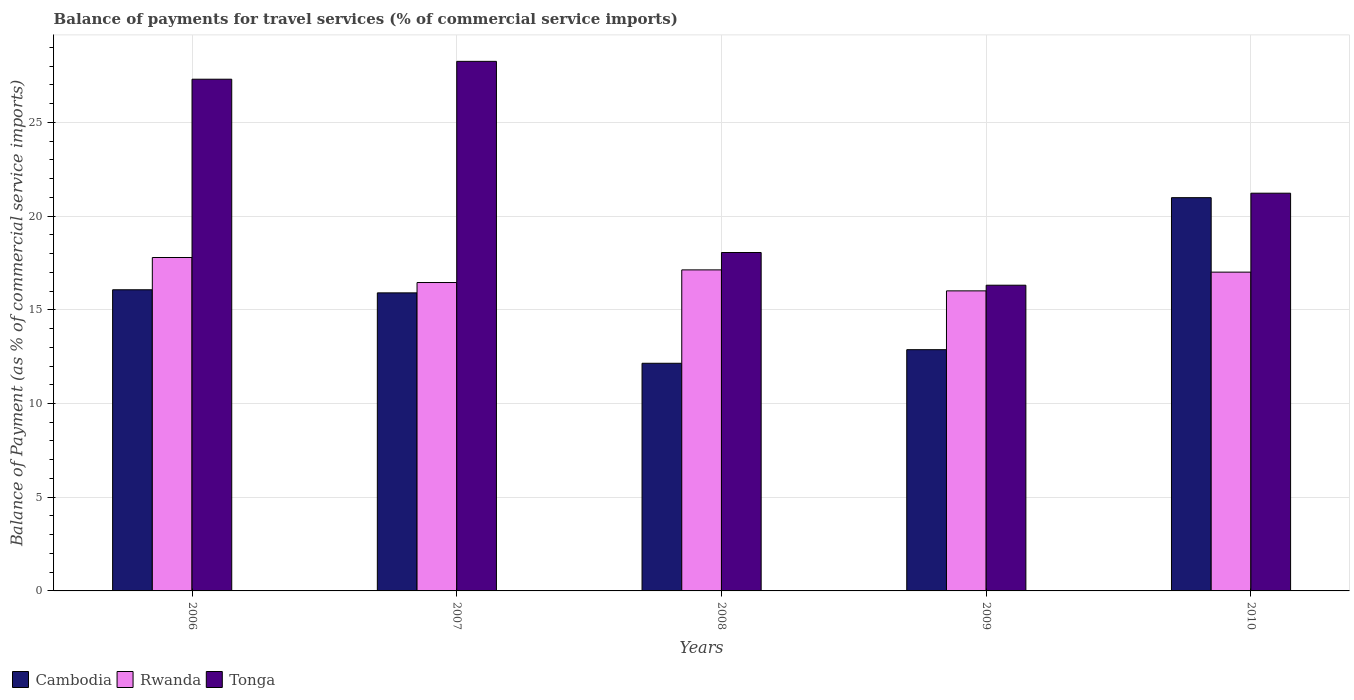How many different coloured bars are there?
Ensure brevity in your answer.  3. How many groups of bars are there?
Ensure brevity in your answer.  5. Are the number of bars per tick equal to the number of legend labels?
Offer a very short reply. Yes. Are the number of bars on each tick of the X-axis equal?
Offer a terse response. Yes. What is the label of the 1st group of bars from the left?
Make the answer very short. 2006. In how many cases, is the number of bars for a given year not equal to the number of legend labels?
Provide a succinct answer. 0. What is the balance of payments for travel services in Cambodia in 2008?
Make the answer very short. 12.15. Across all years, what is the maximum balance of payments for travel services in Rwanda?
Keep it short and to the point. 17.79. Across all years, what is the minimum balance of payments for travel services in Cambodia?
Provide a succinct answer. 12.15. In which year was the balance of payments for travel services in Rwanda minimum?
Provide a short and direct response. 2009. What is the total balance of payments for travel services in Cambodia in the graph?
Give a very brief answer. 77.97. What is the difference between the balance of payments for travel services in Tonga in 2008 and that in 2010?
Provide a succinct answer. -3.16. What is the difference between the balance of payments for travel services in Cambodia in 2008 and the balance of payments for travel services in Tonga in 2006?
Your answer should be very brief. -15.16. What is the average balance of payments for travel services in Cambodia per year?
Provide a succinct answer. 15.59. In the year 2006, what is the difference between the balance of payments for travel services in Cambodia and balance of payments for travel services in Rwanda?
Offer a very short reply. -1.72. What is the ratio of the balance of payments for travel services in Cambodia in 2008 to that in 2010?
Make the answer very short. 0.58. Is the balance of payments for travel services in Rwanda in 2006 less than that in 2010?
Your response must be concise. No. Is the difference between the balance of payments for travel services in Cambodia in 2006 and 2007 greater than the difference between the balance of payments for travel services in Rwanda in 2006 and 2007?
Your response must be concise. No. What is the difference between the highest and the second highest balance of payments for travel services in Tonga?
Give a very brief answer. 0.95. What is the difference between the highest and the lowest balance of payments for travel services in Cambodia?
Your response must be concise. 8.84. In how many years, is the balance of payments for travel services in Tonga greater than the average balance of payments for travel services in Tonga taken over all years?
Offer a terse response. 2. Is the sum of the balance of payments for travel services in Cambodia in 2006 and 2008 greater than the maximum balance of payments for travel services in Rwanda across all years?
Your answer should be very brief. Yes. What does the 3rd bar from the left in 2010 represents?
Make the answer very short. Tonga. What does the 2nd bar from the right in 2008 represents?
Provide a short and direct response. Rwanda. Is it the case that in every year, the sum of the balance of payments for travel services in Cambodia and balance of payments for travel services in Rwanda is greater than the balance of payments for travel services in Tonga?
Give a very brief answer. Yes. How many bars are there?
Make the answer very short. 15. Are all the bars in the graph horizontal?
Provide a succinct answer. No. How many years are there in the graph?
Offer a terse response. 5. Does the graph contain any zero values?
Make the answer very short. No. Does the graph contain grids?
Provide a succinct answer. Yes. Where does the legend appear in the graph?
Keep it short and to the point. Bottom left. How are the legend labels stacked?
Your answer should be very brief. Horizontal. What is the title of the graph?
Your answer should be compact. Balance of payments for travel services (% of commercial service imports). Does "China" appear as one of the legend labels in the graph?
Keep it short and to the point. No. What is the label or title of the Y-axis?
Give a very brief answer. Balance of Payment (as % of commercial service imports). What is the Balance of Payment (as % of commercial service imports) in Cambodia in 2006?
Provide a short and direct response. 16.07. What is the Balance of Payment (as % of commercial service imports) of Rwanda in 2006?
Your answer should be very brief. 17.79. What is the Balance of Payment (as % of commercial service imports) of Tonga in 2006?
Offer a very short reply. 27.3. What is the Balance of Payment (as % of commercial service imports) in Cambodia in 2007?
Your response must be concise. 15.9. What is the Balance of Payment (as % of commercial service imports) of Rwanda in 2007?
Your answer should be very brief. 16.45. What is the Balance of Payment (as % of commercial service imports) of Tonga in 2007?
Ensure brevity in your answer.  28.25. What is the Balance of Payment (as % of commercial service imports) in Cambodia in 2008?
Ensure brevity in your answer.  12.15. What is the Balance of Payment (as % of commercial service imports) in Rwanda in 2008?
Provide a succinct answer. 17.13. What is the Balance of Payment (as % of commercial service imports) of Tonga in 2008?
Ensure brevity in your answer.  18.06. What is the Balance of Payment (as % of commercial service imports) in Cambodia in 2009?
Provide a succinct answer. 12.87. What is the Balance of Payment (as % of commercial service imports) of Rwanda in 2009?
Provide a short and direct response. 16.01. What is the Balance of Payment (as % of commercial service imports) of Tonga in 2009?
Your answer should be compact. 16.31. What is the Balance of Payment (as % of commercial service imports) in Cambodia in 2010?
Offer a terse response. 20.98. What is the Balance of Payment (as % of commercial service imports) of Rwanda in 2010?
Keep it short and to the point. 17.01. What is the Balance of Payment (as % of commercial service imports) in Tonga in 2010?
Give a very brief answer. 21.22. Across all years, what is the maximum Balance of Payment (as % of commercial service imports) in Cambodia?
Ensure brevity in your answer.  20.98. Across all years, what is the maximum Balance of Payment (as % of commercial service imports) in Rwanda?
Offer a terse response. 17.79. Across all years, what is the maximum Balance of Payment (as % of commercial service imports) of Tonga?
Ensure brevity in your answer.  28.25. Across all years, what is the minimum Balance of Payment (as % of commercial service imports) in Cambodia?
Your response must be concise. 12.15. Across all years, what is the minimum Balance of Payment (as % of commercial service imports) in Rwanda?
Your response must be concise. 16.01. Across all years, what is the minimum Balance of Payment (as % of commercial service imports) of Tonga?
Your answer should be compact. 16.31. What is the total Balance of Payment (as % of commercial service imports) in Cambodia in the graph?
Your response must be concise. 77.97. What is the total Balance of Payment (as % of commercial service imports) of Rwanda in the graph?
Keep it short and to the point. 84.39. What is the total Balance of Payment (as % of commercial service imports) of Tonga in the graph?
Your answer should be compact. 111.14. What is the difference between the Balance of Payment (as % of commercial service imports) in Cambodia in 2006 and that in 2007?
Provide a short and direct response. 0.17. What is the difference between the Balance of Payment (as % of commercial service imports) in Rwanda in 2006 and that in 2007?
Provide a short and direct response. 1.34. What is the difference between the Balance of Payment (as % of commercial service imports) of Tonga in 2006 and that in 2007?
Your answer should be very brief. -0.95. What is the difference between the Balance of Payment (as % of commercial service imports) in Cambodia in 2006 and that in 2008?
Your response must be concise. 3.92. What is the difference between the Balance of Payment (as % of commercial service imports) of Rwanda in 2006 and that in 2008?
Keep it short and to the point. 0.66. What is the difference between the Balance of Payment (as % of commercial service imports) in Tonga in 2006 and that in 2008?
Ensure brevity in your answer.  9.25. What is the difference between the Balance of Payment (as % of commercial service imports) in Cambodia in 2006 and that in 2009?
Keep it short and to the point. 3.2. What is the difference between the Balance of Payment (as % of commercial service imports) of Rwanda in 2006 and that in 2009?
Ensure brevity in your answer.  1.78. What is the difference between the Balance of Payment (as % of commercial service imports) in Tonga in 2006 and that in 2009?
Give a very brief answer. 10.99. What is the difference between the Balance of Payment (as % of commercial service imports) in Cambodia in 2006 and that in 2010?
Your response must be concise. -4.91. What is the difference between the Balance of Payment (as % of commercial service imports) in Rwanda in 2006 and that in 2010?
Your response must be concise. 0.78. What is the difference between the Balance of Payment (as % of commercial service imports) of Tonga in 2006 and that in 2010?
Give a very brief answer. 6.08. What is the difference between the Balance of Payment (as % of commercial service imports) in Cambodia in 2007 and that in 2008?
Provide a short and direct response. 3.76. What is the difference between the Balance of Payment (as % of commercial service imports) in Rwanda in 2007 and that in 2008?
Offer a terse response. -0.67. What is the difference between the Balance of Payment (as % of commercial service imports) of Tonga in 2007 and that in 2008?
Your response must be concise. 10.2. What is the difference between the Balance of Payment (as % of commercial service imports) in Cambodia in 2007 and that in 2009?
Make the answer very short. 3.03. What is the difference between the Balance of Payment (as % of commercial service imports) in Rwanda in 2007 and that in 2009?
Give a very brief answer. 0.45. What is the difference between the Balance of Payment (as % of commercial service imports) in Tonga in 2007 and that in 2009?
Give a very brief answer. 11.94. What is the difference between the Balance of Payment (as % of commercial service imports) of Cambodia in 2007 and that in 2010?
Keep it short and to the point. -5.08. What is the difference between the Balance of Payment (as % of commercial service imports) in Rwanda in 2007 and that in 2010?
Offer a terse response. -0.56. What is the difference between the Balance of Payment (as % of commercial service imports) of Tonga in 2007 and that in 2010?
Keep it short and to the point. 7.03. What is the difference between the Balance of Payment (as % of commercial service imports) in Cambodia in 2008 and that in 2009?
Ensure brevity in your answer.  -0.73. What is the difference between the Balance of Payment (as % of commercial service imports) in Rwanda in 2008 and that in 2009?
Provide a succinct answer. 1.12. What is the difference between the Balance of Payment (as % of commercial service imports) in Tonga in 2008 and that in 2009?
Offer a terse response. 1.74. What is the difference between the Balance of Payment (as % of commercial service imports) in Cambodia in 2008 and that in 2010?
Provide a short and direct response. -8.84. What is the difference between the Balance of Payment (as % of commercial service imports) of Rwanda in 2008 and that in 2010?
Ensure brevity in your answer.  0.12. What is the difference between the Balance of Payment (as % of commercial service imports) in Tonga in 2008 and that in 2010?
Keep it short and to the point. -3.16. What is the difference between the Balance of Payment (as % of commercial service imports) in Cambodia in 2009 and that in 2010?
Your answer should be compact. -8.11. What is the difference between the Balance of Payment (as % of commercial service imports) in Rwanda in 2009 and that in 2010?
Your answer should be very brief. -1. What is the difference between the Balance of Payment (as % of commercial service imports) in Tonga in 2009 and that in 2010?
Ensure brevity in your answer.  -4.91. What is the difference between the Balance of Payment (as % of commercial service imports) of Cambodia in 2006 and the Balance of Payment (as % of commercial service imports) of Rwanda in 2007?
Give a very brief answer. -0.39. What is the difference between the Balance of Payment (as % of commercial service imports) in Cambodia in 2006 and the Balance of Payment (as % of commercial service imports) in Tonga in 2007?
Ensure brevity in your answer.  -12.19. What is the difference between the Balance of Payment (as % of commercial service imports) in Rwanda in 2006 and the Balance of Payment (as % of commercial service imports) in Tonga in 2007?
Your answer should be compact. -10.47. What is the difference between the Balance of Payment (as % of commercial service imports) in Cambodia in 2006 and the Balance of Payment (as % of commercial service imports) in Rwanda in 2008?
Ensure brevity in your answer.  -1.06. What is the difference between the Balance of Payment (as % of commercial service imports) of Cambodia in 2006 and the Balance of Payment (as % of commercial service imports) of Tonga in 2008?
Offer a very short reply. -1.99. What is the difference between the Balance of Payment (as % of commercial service imports) of Rwanda in 2006 and the Balance of Payment (as % of commercial service imports) of Tonga in 2008?
Your answer should be compact. -0.27. What is the difference between the Balance of Payment (as % of commercial service imports) in Cambodia in 2006 and the Balance of Payment (as % of commercial service imports) in Rwanda in 2009?
Your answer should be compact. 0.06. What is the difference between the Balance of Payment (as % of commercial service imports) in Cambodia in 2006 and the Balance of Payment (as % of commercial service imports) in Tonga in 2009?
Your answer should be compact. -0.24. What is the difference between the Balance of Payment (as % of commercial service imports) of Rwanda in 2006 and the Balance of Payment (as % of commercial service imports) of Tonga in 2009?
Make the answer very short. 1.48. What is the difference between the Balance of Payment (as % of commercial service imports) of Cambodia in 2006 and the Balance of Payment (as % of commercial service imports) of Rwanda in 2010?
Make the answer very short. -0.94. What is the difference between the Balance of Payment (as % of commercial service imports) in Cambodia in 2006 and the Balance of Payment (as % of commercial service imports) in Tonga in 2010?
Offer a very short reply. -5.15. What is the difference between the Balance of Payment (as % of commercial service imports) in Rwanda in 2006 and the Balance of Payment (as % of commercial service imports) in Tonga in 2010?
Provide a short and direct response. -3.43. What is the difference between the Balance of Payment (as % of commercial service imports) in Cambodia in 2007 and the Balance of Payment (as % of commercial service imports) in Rwanda in 2008?
Your answer should be very brief. -1.23. What is the difference between the Balance of Payment (as % of commercial service imports) in Cambodia in 2007 and the Balance of Payment (as % of commercial service imports) in Tonga in 2008?
Provide a succinct answer. -2.15. What is the difference between the Balance of Payment (as % of commercial service imports) of Rwanda in 2007 and the Balance of Payment (as % of commercial service imports) of Tonga in 2008?
Ensure brevity in your answer.  -1.6. What is the difference between the Balance of Payment (as % of commercial service imports) in Cambodia in 2007 and the Balance of Payment (as % of commercial service imports) in Rwanda in 2009?
Make the answer very short. -0.11. What is the difference between the Balance of Payment (as % of commercial service imports) in Cambodia in 2007 and the Balance of Payment (as % of commercial service imports) in Tonga in 2009?
Provide a succinct answer. -0.41. What is the difference between the Balance of Payment (as % of commercial service imports) of Rwanda in 2007 and the Balance of Payment (as % of commercial service imports) of Tonga in 2009?
Provide a short and direct response. 0.14. What is the difference between the Balance of Payment (as % of commercial service imports) of Cambodia in 2007 and the Balance of Payment (as % of commercial service imports) of Rwanda in 2010?
Make the answer very short. -1.11. What is the difference between the Balance of Payment (as % of commercial service imports) of Cambodia in 2007 and the Balance of Payment (as % of commercial service imports) of Tonga in 2010?
Ensure brevity in your answer.  -5.32. What is the difference between the Balance of Payment (as % of commercial service imports) of Rwanda in 2007 and the Balance of Payment (as % of commercial service imports) of Tonga in 2010?
Offer a very short reply. -4.77. What is the difference between the Balance of Payment (as % of commercial service imports) of Cambodia in 2008 and the Balance of Payment (as % of commercial service imports) of Rwanda in 2009?
Your response must be concise. -3.86. What is the difference between the Balance of Payment (as % of commercial service imports) of Cambodia in 2008 and the Balance of Payment (as % of commercial service imports) of Tonga in 2009?
Make the answer very short. -4.17. What is the difference between the Balance of Payment (as % of commercial service imports) in Rwanda in 2008 and the Balance of Payment (as % of commercial service imports) in Tonga in 2009?
Your answer should be compact. 0.82. What is the difference between the Balance of Payment (as % of commercial service imports) in Cambodia in 2008 and the Balance of Payment (as % of commercial service imports) in Rwanda in 2010?
Keep it short and to the point. -4.86. What is the difference between the Balance of Payment (as % of commercial service imports) of Cambodia in 2008 and the Balance of Payment (as % of commercial service imports) of Tonga in 2010?
Make the answer very short. -9.07. What is the difference between the Balance of Payment (as % of commercial service imports) in Rwanda in 2008 and the Balance of Payment (as % of commercial service imports) in Tonga in 2010?
Your answer should be compact. -4.09. What is the difference between the Balance of Payment (as % of commercial service imports) in Cambodia in 2009 and the Balance of Payment (as % of commercial service imports) in Rwanda in 2010?
Make the answer very short. -4.14. What is the difference between the Balance of Payment (as % of commercial service imports) in Cambodia in 2009 and the Balance of Payment (as % of commercial service imports) in Tonga in 2010?
Your answer should be compact. -8.35. What is the difference between the Balance of Payment (as % of commercial service imports) of Rwanda in 2009 and the Balance of Payment (as % of commercial service imports) of Tonga in 2010?
Offer a very short reply. -5.21. What is the average Balance of Payment (as % of commercial service imports) in Cambodia per year?
Offer a very short reply. 15.59. What is the average Balance of Payment (as % of commercial service imports) of Rwanda per year?
Ensure brevity in your answer.  16.88. What is the average Balance of Payment (as % of commercial service imports) in Tonga per year?
Your response must be concise. 22.23. In the year 2006, what is the difference between the Balance of Payment (as % of commercial service imports) in Cambodia and Balance of Payment (as % of commercial service imports) in Rwanda?
Provide a succinct answer. -1.72. In the year 2006, what is the difference between the Balance of Payment (as % of commercial service imports) in Cambodia and Balance of Payment (as % of commercial service imports) in Tonga?
Provide a succinct answer. -11.23. In the year 2006, what is the difference between the Balance of Payment (as % of commercial service imports) in Rwanda and Balance of Payment (as % of commercial service imports) in Tonga?
Your answer should be very brief. -9.51. In the year 2007, what is the difference between the Balance of Payment (as % of commercial service imports) of Cambodia and Balance of Payment (as % of commercial service imports) of Rwanda?
Your answer should be very brief. -0.55. In the year 2007, what is the difference between the Balance of Payment (as % of commercial service imports) of Cambodia and Balance of Payment (as % of commercial service imports) of Tonga?
Give a very brief answer. -12.35. In the year 2007, what is the difference between the Balance of Payment (as % of commercial service imports) in Rwanda and Balance of Payment (as % of commercial service imports) in Tonga?
Your answer should be very brief. -11.8. In the year 2008, what is the difference between the Balance of Payment (as % of commercial service imports) in Cambodia and Balance of Payment (as % of commercial service imports) in Rwanda?
Your answer should be very brief. -4.98. In the year 2008, what is the difference between the Balance of Payment (as % of commercial service imports) of Cambodia and Balance of Payment (as % of commercial service imports) of Tonga?
Give a very brief answer. -5.91. In the year 2008, what is the difference between the Balance of Payment (as % of commercial service imports) in Rwanda and Balance of Payment (as % of commercial service imports) in Tonga?
Your answer should be compact. -0.93. In the year 2009, what is the difference between the Balance of Payment (as % of commercial service imports) of Cambodia and Balance of Payment (as % of commercial service imports) of Rwanda?
Offer a terse response. -3.14. In the year 2009, what is the difference between the Balance of Payment (as % of commercial service imports) in Cambodia and Balance of Payment (as % of commercial service imports) in Tonga?
Offer a terse response. -3.44. In the year 2009, what is the difference between the Balance of Payment (as % of commercial service imports) in Rwanda and Balance of Payment (as % of commercial service imports) in Tonga?
Your answer should be compact. -0.3. In the year 2010, what is the difference between the Balance of Payment (as % of commercial service imports) of Cambodia and Balance of Payment (as % of commercial service imports) of Rwanda?
Your answer should be compact. 3.97. In the year 2010, what is the difference between the Balance of Payment (as % of commercial service imports) in Cambodia and Balance of Payment (as % of commercial service imports) in Tonga?
Make the answer very short. -0.24. In the year 2010, what is the difference between the Balance of Payment (as % of commercial service imports) in Rwanda and Balance of Payment (as % of commercial service imports) in Tonga?
Provide a short and direct response. -4.21. What is the ratio of the Balance of Payment (as % of commercial service imports) of Cambodia in 2006 to that in 2007?
Your response must be concise. 1.01. What is the ratio of the Balance of Payment (as % of commercial service imports) of Rwanda in 2006 to that in 2007?
Keep it short and to the point. 1.08. What is the ratio of the Balance of Payment (as % of commercial service imports) in Tonga in 2006 to that in 2007?
Provide a succinct answer. 0.97. What is the ratio of the Balance of Payment (as % of commercial service imports) of Cambodia in 2006 to that in 2008?
Offer a terse response. 1.32. What is the ratio of the Balance of Payment (as % of commercial service imports) of Rwanda in 2006 to that in 2008?
Offer a very short reply. 1.04. What is the ratio of the Balance of Payment (as % of commercial service imports) of Tonga in 2006 to that in 2008?
Make the answer very short. 1.51. What is the ratio of the Balance of Payment (as % of commercial service imports) in Cambodia in 2006 to that in 2009?
Your answer should be compact. 1.25. What is the ratio of the Balance of Payment (as % of commercial service imports) of Rwanda in 2006 to that in 2009?
Offer a terse response. 1.11. What is the ratio of the Balance of Payment (as % of commercial service imports) in Tonga in 2006 to that in 2009?
Provide a short and direct response. 1.67. What is the ratio of the Balance of Payment (as % of commercial service imports) in Cambodia in 2006 to that in 2010?
Ensure brevity in your answer.  0.77. What is the ratio of the Balance of Payment (as % of commercial service imports) of Rwanda in 2006 to that in 2010?
Give a very brief answer. 1.05. What is the ratio of the Balance of Payment (as % of commercial service imports) of Tonga in 2006 to that in 2010?
Your answer should be very brief. 1.29. What is the ratio of the Balance of Payment (as % of commercial service imports) in Cambodia in 2007 to that in 2008?
Keep it short and to the point. 1.31. What is the ratio of the Balance of Payment (as % of commercial service imports) in Rwanda in 2007 to that in 2008?
Provide a short and direct response. 0.96. What is the ratio of the Balance of Payment (as % of commercial service imports) of Tonga in 2007 to that in 2008?
Provide a succinct answer. 1.56. What is the ratio of the Balance of Payment (as % of commercial service imports) in Cambodia in 2007 to that in 2009?
Your answer should be compact. 1.24. What is the ratio of the Balance of Payment (as % of commercial service imports) of Rwanda in 2007 to that in 2009?
Your response must be concise. 1.03. What is the ratio of the Balance of Payment (as % of commercial service imports) of Tonga in 2007 to that in 2009?
Your answer should be very brief. 1.73. What is the ratio of the Balance of Payment (as % of commercial service imports) of Cambodia in 2007 to that in 2010?
Offer a very short reply. 0.76. What is the ratio of the Balance of Payment (as % of commercial service imports) of Rwanda in 2007 to that in 2010?
Keep it short and to the point. 0.97. What is the ratio of the Balance of Payment (as % of commercial service imports) of Tonga in 2007 to that in 2010?
Provide a short and direct response. 1.33. What is the ratio of the Balance of Payment (as % of commercial service imports) in Cambodia in 2008 to that in 2009?
Provide a short and direct response. 0.94. What is the ratio of the Balance of Payment (as % of commercial service imports) in Rwanda in 2008 to that in 2009?
Offer a terse response. 1.07. What is the ratio of the Balance of Payment (as % of commercial service imports) of Tonga in 2008 to that in 2009?
Your response must be concise. 1.11. What is the ratio of the Balance of Payment (as % of commercial service imports) in Cambodia in 2008 to that in 2010?
Keep it short and to the point. 0.58. What is the ratio of the Balance of Payment (as % of commercial service imports) of Tonga in 2008 to that in 2010?
Provide a succinct answer. 0.85. What is the ratio of the Balance of Payment (as % of commercial service imports) of Cambodia in 2009 to that in 2010?
Provide a succinct answer. 0.61. What is the ratio of the Balance of Payment (as % of commercial service imports) of Rwanda in 2009 to that in 2010?
Ensure brevity in your answer.  0.94. What is the ratio of the Balance of Payment (as % of commercial service imports) of Tonga in 2009 to that in 2010?
Offer a terse response. 0.77. What is the difference between the highest and the second highest Balance of Payment (as % of commercial service imports) of Cambodia?
Your answer should be very brief. 4.91. What is the difference between the highest and the second highest Balance of Payment (as % of commercial service imports) in Rwanda?
Offer a very short reply. 0.66. What is the difference between the highest and the second highest Balance of Payment (as % of commercial service imports) of Tonga?
Ensure brevity in your answer.  0.95. What is the difference between the highest and the lowest Balance of Payment (as % of commercial service imports) of Cambodia?
Offer a very short reply. 8.84. What is the difference between the highest and the lowest Balance of Payment (as % of commercial service imports) of Rwanda?
Keep it short and to the point. 1.78. What is the difference between the highest and the lowest Balance of Payment (as % of commercial service imports) in Tonga?
Your response must be concise. 11.94. 